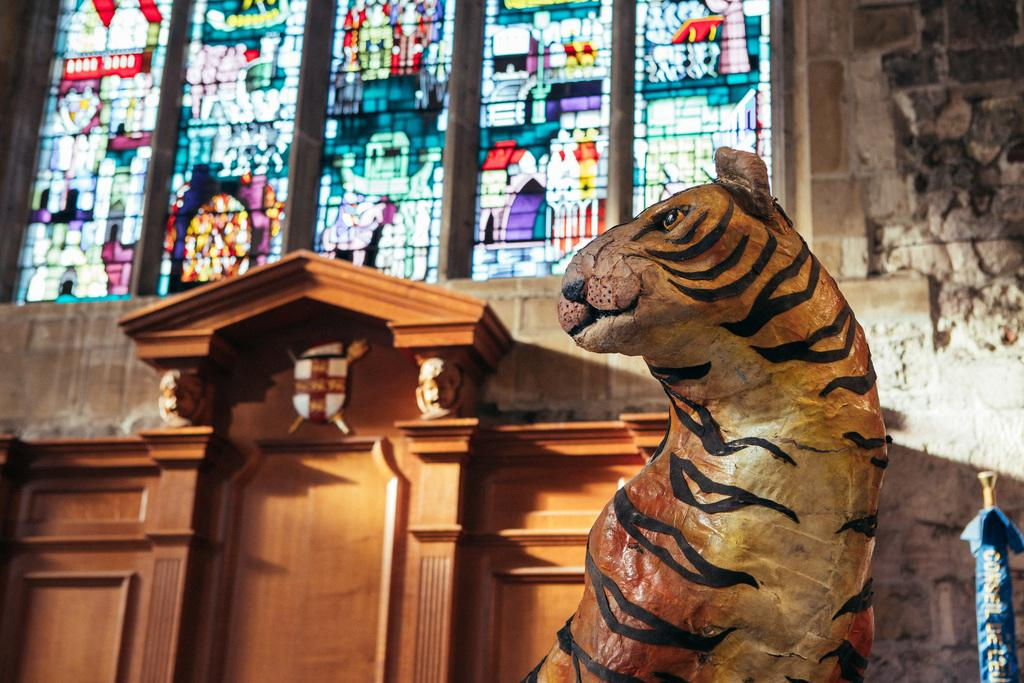What is the main subject of the image? There is a sculpture in the image. Where is the sculpture located in relation to other elements in the image? The sculpture is in front of a wall. Can you describe the feather on the robin that is perched on the sculpture in the image? There is no robin or feather present in the image; it only features a sculpture in front of a wall. 